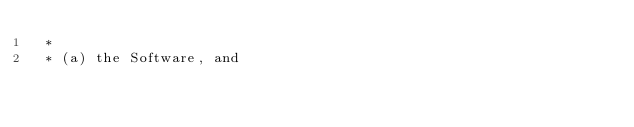<code> <loc_0><loc_0><loc_500><loc_500><_Java_> *
 * (a) the Software, and</code> 